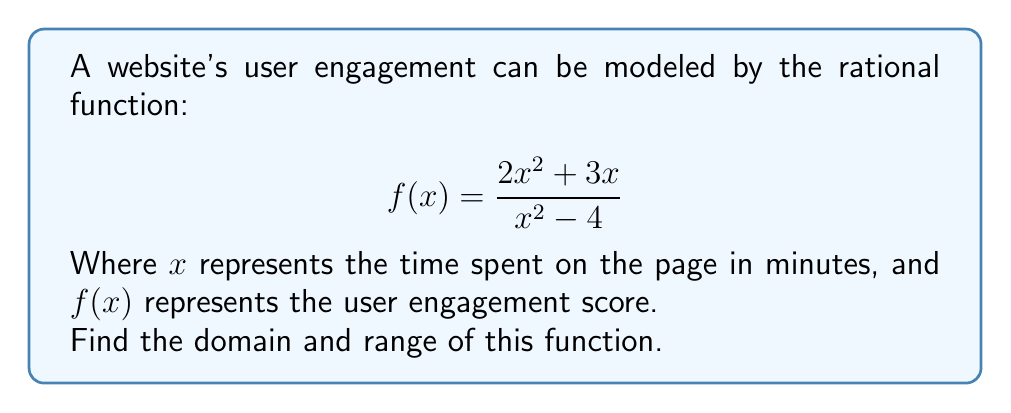Help me with this question. Let's approach this step-by-step:

1) Domain:
   The domain of a rational function includes all real numbers except those that make the denominator zero.
   
   Set the denominator to zero and solve:
   $$x^2 - 4 = 0$$
   $$(x+2)(x-2) = 0$$
   $$x = -2 \text{ or } x = 2$$

   Therefore, the domain is all real numbers except -2 and 2.

2) Range:
   To find the range, let's analyze the behavior of the function:

   a) As $x$ approaches infinity or negative infinity:
      $$\lim_{x \to \pm\infty} \frac{2x^2 + 3x}{x^2 - 4} = \lim_{x \to \pm\infty} \frac{2 + 3/x}{1 - 4/x^2} = 2$$

   b) Find the vertical asymptotes:
      At $x = -2$ and $x = 2$, the function approaches positive or negative infinity.

   c) Find the x-intercept:
      Set $f(x) = 0$:
      $$\frac{2x^2 + 3x}{x^2 - 4} = 0$$
      $$2x^2 + 3x = 0$$
      $$x(2x + 3) = 0$$
      $$x = 0 \text{ or } x = -\frac{3}{2}$$

   d) Find the y-intercept:
      At $x = 0$, $f(0) = 0$

   e) Analyze the behavior between asymptotes:
      The function approaches positive infinity as $x$ approaches 2 from the left and negative infinity from the right.
      It approaches negative infinity as $x$ approaches -2 from the left and positive infinity from the right.

   Given this behavior, the range of the function is all real numbers.
Answer: Domain: $x \in \mathbb{R}, x \neq -2, 2$
Range: $y \in \mathbb{R}$ 